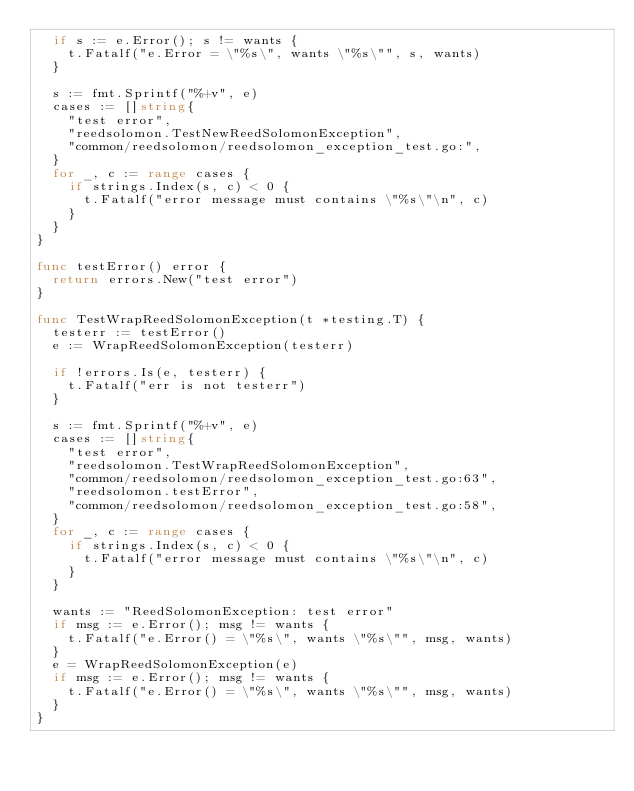Convert code to text. <code><loc_0><loc_0><loc_500><loc_500><_Go_>	if s := e.Error(); s != wants {
		t.Fatalf("e.Error = \"%s\", wants \"%s\"", s, wants)
	}

	s := fmt.Sprintf("%+v", e)
	cases := []string{
		"test error",
		"reedsolomon.TestNewReedSolomonException",
		"common/reedsolomon/reedsolomon_exception_test.go:",
	}
	for _, c := range cases {
		if strings.Index(s, c) < 0 {
			t.Fatalf("error message must contains \"%s\"\n", c)
		}
	}
}

func testError() error {
	return errors.New("test error")
}

func TestWrapReedSolomonException(t *testing.T) {
	testerr := testError()
	e := WrapReedSolomonException(testerr)

	if !errors.Is(e, testerr) {
		t.Fatalf("err is not testerr")
	}

	s := fmt.Sprintf("%+v", e)
	cases := []string{
		"test error",
		"reedsolomon.TestWrapReedSolomonException",
		"common/reedsolomon/reedsolomon_exception_test.go:63",
		"reedsolomon.testError",
		"common/reedsolomon/reedsolomon_exception_test.go:58",
	}
	for _, c := range cases {
		if strings.Index(s, c) < 0 {
			t.Fatalf("error message must contains \"%s\"\n", c)
		}
	}

	wants := "ReedSolomonException: test error"
	if msg := e.Error(); msg != wants {
		t.Fatalf("e.Error() = \"%s\", wants \"%s\"", msg, wants)
	}
	e = WrapReedSolomonException(e)
	if msg := e.Error(); msg != wants {
		t.Fatalf("e.Error() = \"%s\", wants \"%s\"", msg, wants)
	}
}
</code> 